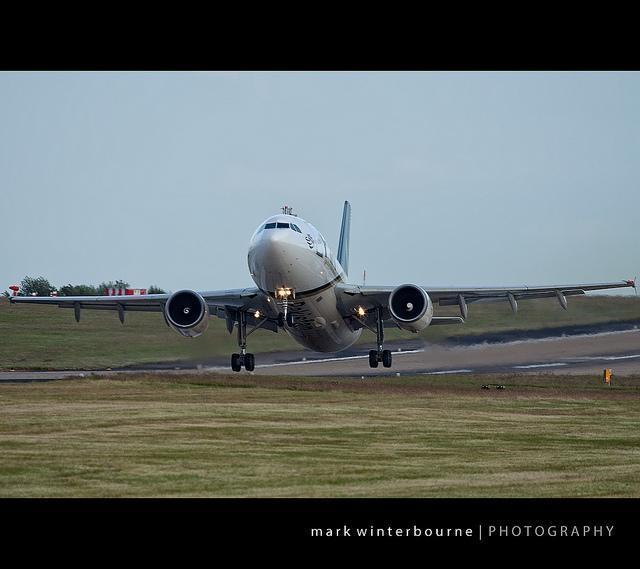How many lights can you see on the plane?
Give a very brief answer. 3. How many engines does the plane have?
Give a very brief answer. 2. 